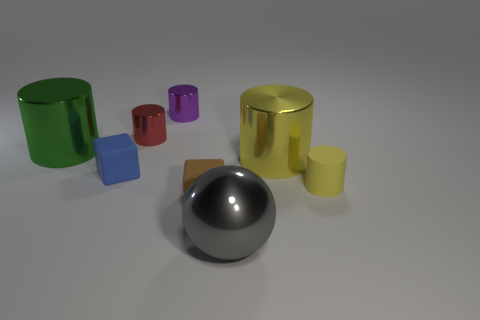Subtract all yellow rubber cylinders. How many cylinders are left? 4 Add 1 cylinders. How many objects exist? 9 Subtract all green cylinders. How many cylinders are left? 4 Subtract 0 purple balls. How many objects are left? 8 Subtract all cubes. How many objects are left? 6 Subtract 1 cubes. How many cubes are left? 1 Subtract all gray blocks. Subtract all purple cylinders. How many blocks are left? 2 Subtract all red spheres. How many yellow cylinders are left? 2 Subtract all green metal things. Subtract all brown cubes. How many objects are left? 6 Add 1 brown rubber objects. How many brown rubber objects are left? 2 